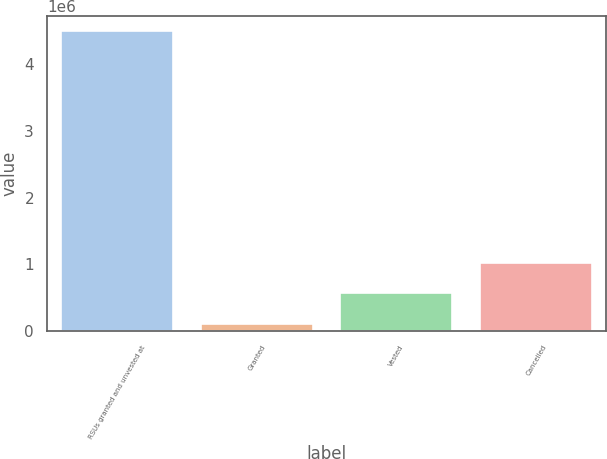Convert chart. <chart><loc_0><loc_0><loc_500><loc_500><bar_chart><fcel>RSUs granted and unvested at<fcel>Granted<fcel>Vested<fcel>Cancelled<nl><fcel>4.49152e+06<fcel>108400<fcel>567672<fcel>1.02694e+06<nl></chart> 